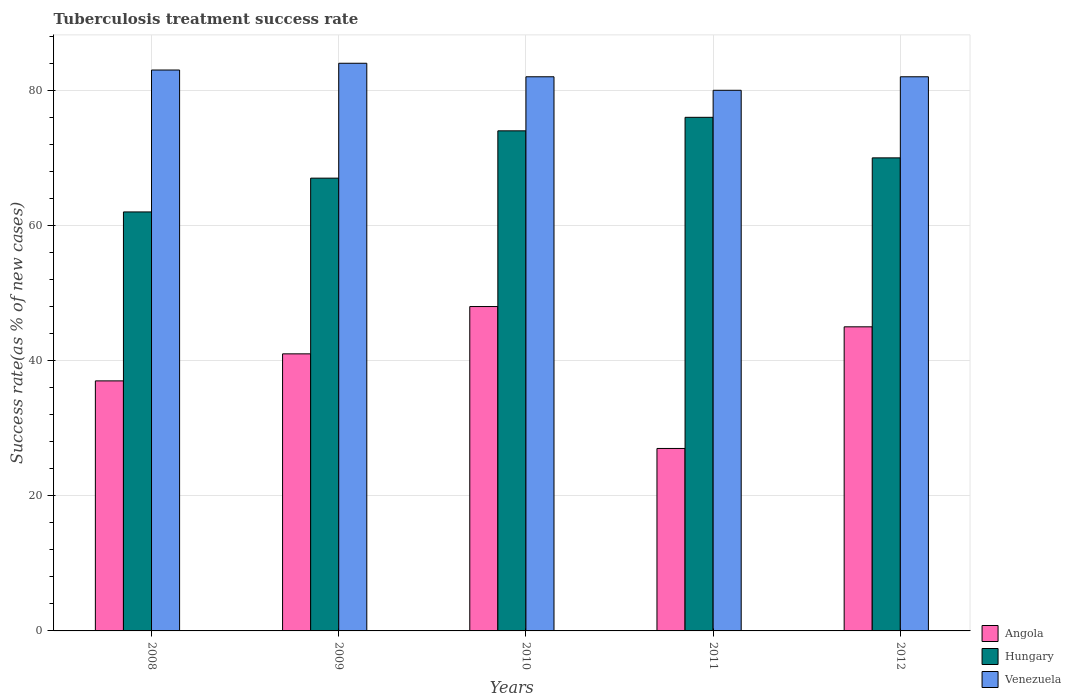How many groups of bars are there?
Offer a very short reply. 5. Are the number of bars on each tick of the X-axis equal?
Provide a succinct answer. Yes. In how many cases, is the number of bars for a given year not equal to the number of legend labels?
Ensure brevity in your answer.  0. What is the tuberculosis treatment success rate in Venezuela in 2008?
Offer a terse response. 83. In which year was the tuberculosis treatment success rate in Hungary maximum?
Ensure brevity in your answer.  2011. What is the total tuberculosis treatment success rate in Venezuela in the graph?
Keep it short and to the point. 411. What is the difference between the tuberculosis treatment success rate in Venezuela in 2008 and that in 2012?
Give a very brief answer. 1. What is the difference between the tuberculosis treatment success rate in Venezuela in 2008 and the tuberculosis treatment success rate in Angola in 2010?
Offer a very short reply. 35. What is the average tuberculosis treatment success rate in Venezuela per year?
Provide a short and direct response. 82.2. What is the ratio of the tuberculosis treatment success rate in Angola in 2010 to that in 2012?
Give a very brief answer. 1.07. Is the tuberculosis treatment success rate in Venezuela in 2009 less than that in 2011?
Make the answer very short. No. Is the difference between the tuberculosis treatment success rate in Venezuela in 2008 and 2011 greater than the difference between the tuberculosis treatment success rate in Hungary in 2008 and 2011?
Ensure brevity in your answer.  Yes. What is the difference between the highest and the lowest tuberculosis treatment success rate in Venezuela?
Make the answer very short. 4. In how many years, is the tuberculosis treatment success rate in Venezuela greater than the average tuberculosis treatment success rate in Venezuela taken over all years?
Offer a very short reply. 2. What does the 2nd bar from the left in 2009 represents?
Your answer should be very brief. Hungary. What does the 3rd bar from the right in 2008 represents?
Offer a terse response. Angola. Are all the bars in the graph horizontal?
Give a very brief answer. No. How many years are there in the graph?
Provide a short and direct response. 5. What is the difference between two consecutive major ticks on the Y-axis?
Ensure brevity in your answer.  20. Does the graph contain grids?
Your answer should be very brief. Yes. Where does the legend appear in the graph?
Keep it short and to the point. Bottom right. How many legend labels are there?
Make the answer very short. 3. How are the legend labels stacked?
Your answer should be compact. Vertical. What is the title of the graph?
Offer a very short reply. Tuberculosis treatment success rate. Does "Uzbekistan" appear as one of the legend labels in the graph?
Your answer should be very brief. No. What is the label or title of the Y-axis?
Provide a succinct answer. Success rate(as % of new cases). What is the Success rate(as % of new cases) in Hungary in 2008?
Give a very brief answer. 62. What is the Success rate(as % of new cases) in Venezuela in 2008?
Your answer should be very brief. 83. What is the Success rate(as % of new cases) of Hungary in 2010?
Offer a very short reply. 74. What is the Success rate(as % of new cases) of Venezuela in 2010?
Your answer should be very brief. 82. What is the Success rate(as % of new cases) in Angola in 2011?
Your response must be concise. 27. What is the Success rate(as % of new cases) of Hungary in 2011?
Your answer should be compact. 76. What is the Success rate(as % of new cases) in Angola in 2012?
Provide a succinct answer. 45. What is the Success rate(as % of new cases) of Hungary in 2012?
Your response must be concise. 70. Across all years, what is the maximum Success rate(as % of new cases) of Angola?
Provide a short and direct response. 48. Across all years, what is the maximum Success rate(as % of new cases) of Hungary?
Ensure brevity in your answer.  76. Across all years, what is the minimum Success rate(as % of new cases) in Venezuela?
Your answer should be very brief. 80. What is the total Success rate(as % of new cases) in Angola in the graph?
Your answer should be compact. 198. What is the total Success rate(as % of new cases) of Hungary in the graph?
Ensure brevity in your answer.  349. What is the total Success rate(as % of new cases) of Venezuela in the graph?
Give a very brief answer. 411. What is the difference between the Success rate(as % of new cases) of Venezuela in 2008 and that in 2009?
Your response must be concise. -1. What is the difference between the Success rate(as % of new cases) in Hungary in 2008 and that in 2011?
Make the answer very short. -14. What is the difference between the Success rate(as % of new cases) in Angola in 2008 and that in 2012?
Provide a succinct answer. -8. What is the difference between the Success rate(as % of new cases) of Hungary in 2008 and that in 2012?
Offer a very short reply. -8. What is the difference between the Success rate(as % of new cases) in Angola in 2009 and that in 2010?
Ensure brevity in your answer.  -7. What is the difference between the Success rate(as % of new cases) in Hungary in 2009 and that in 2010?
Your answer should be very brief. -7. What is the difference between the Success rate(as % of new cases) of Venezuela in 2009 and that in 2010?
Your answer should be very brief. 2. What is the difference between the Success rate(as % of new cases) of Venezuela in 2009 and that in 2011?
Offer a very short reply. 4. What is the difference between the Success rate(as % of new cases) of Angola in 2010 and that in 2011?
Offer a very short reply. 21. What is the difference between the Success rate(as % of new cases) of Venezuela in 2010 and that in 2011?
Your answer should be compact. 2. What is the difference between the Success rate(as % of new cases) of Venezuela in 2011 and that in 2012?
Your answer should be compact. -2. What is the difference between the Success rate(as % of new cases) of Angola in 2008 and the Success rate(as % of new cases) of Venezuela in 2009?
Give a very brief answer. -47. What is the difference between the Success rate(as % of new cases) of Hungary in 2008 and the Success rate(as % of new cases) of Venezuela in 2009?
Give a very brief answer. -22. What is the difference between the Success rate(as % of new cases) in Angola in 2008 and the Success rate(as % of new cases) in Hungary in 2010?
Offer a terse response. -37. What is the difference between the Success rate(as % of new cases) of Angola in 2008 and the Success rate(as % of new cases) of Venezuela in 2010?
Keep it short and to the point. -45. What is the difference between the Success rate(as % of new cases) of Hungary in 2008 and the Success rate(as % of new cases) of Venezuela in 2010?
Your response must be concise. -20. What is the difference between the Success rate(as % of new cases) of Angola in 2008 and the Success rate(as % of new cases) of Hungary in 2011?
Give a very brief answer. -39. What is the difference between the Success rate(as % of new cases) in Angola in 2008 and the Success rate(as % of new cases) in Venezuela in 2011?
Give a very brief answer. -43. What is the difference between the Success rate(as % of new cases) of Angola in 2008 and the Success rate(as % of new cases) of Hungary in 2012?
Offer a very short reply. -33. What is the difference between the Success rate(as % of new cases) in Angola in 2008 and the Success rate(as % of new cases) in Venezuela in 2012?
Make the answer very short. -45. What is the difference between the Success rate(as % of new cases) in Hungary in 2008 and the Success rate(as % of new cases) in Venezuela in 2012?
Keep it short and to the point. -20. What is the difference between the Success rate(as % of new cases) in Angola in 2009 and the Success rate(as % of new cases) in Hungary in 2010?
Offer a very short reply. -33. What is the difference between the Success rate(as % of new cases) of Angola in 2009 and the Success rate(as % of new cases) of Venezuela in 2010?
Keep it short and to the point. -41. What is the difference between the Success rate(as % of new cases) in Hungary in 2009 and the Success rate(as % of new cases) in Venezuela in 2010?
Give a very brief answer. -15. What is the difference between the Success rate(as % of new cases) of Angola in 2009 and the Success rate(as % of new cases) of Hungary in 2011?
Offer a terse response. -35. What is the difference between the Success rate(as % of new cases) of Angola in 2009 and the Success rate(as % of new cases) of Venezuela in 2011?
Make the answer very short. -39. What is the difference between the Success rate(as % of new cases) in Hungary in 2009 and the Success rate(as % of new cases) in Venezuela in 2011?
Your response must be concise. -13. What is the difference between the Success rate(as % of new cases) of Angola in 2009 and the Success rate(as % of new cases) of Venezuela in 2012?
Your answer should be compact. -41. What is the difference between the Success rate(as % of new cases) of Hungary in 2009 and the Success rate(as % of new cases) of Venezuela in 2012?
Offer a terse response. -15. What is the difference between the Success rate(as % of new cases) of Angola in 2010 and the Success rate(as % of new cases) of Hungary in 2011?
Your response must be concise. -28. What is the difference between the Success rate(as % of new cases) in Angola in 2010 and the Success rate(as % of new cases) in Venezuela in 2011?
Give a very brief answer. -32. What is the difference between the Success rate(as % of new cases) of Hungary in 2010 and the Success rate(as % of new cases) of Venezuela in 2011?
Your answer should be compact. -6. What is the difference between the Success rate(as % of new cases) in Angola in 2010 and the Success rate(as % of new cases) in Venezuela in 2012?
Your answer should be compact. -34. What is the difference between the Success rate(as % of new cases) in Hungary in 2010 and the Success rate(as % of new cases) in Venezuela in 2012?
Offer a terse response. -8. What is the difference between the Success rate(as % of new cases) in Angola in 2011 and the Success rate(as % of new cases) in Hungary in 2012?
Your answer should be very brief. -43. What is the difference between the Success rate(as % of new cases) in Angola in 2011 and the Success rate(as % of new cases) in Venezuela in 2012?
Your answer should be very brief. -55. What is the difference between the Success rate(as % of new cases) of Hungary in 2011 and the Success rate(as % of new cases) of Venezuela in 2012?
Make the answer very short. -6. What is the average Success rate(as % of new cases) in Angola per year?
Offer a very short reply. 39.6. What is the average Success rate(as % of new cases) in Hungary per year?
Provide a short and direct response. 69.8. What is the average Success rate(as % of new cases) of Venezuela per year?
Your answer should be very brief. 82.2. In the year 2008, what is the difference between the Success rate(as % of new cases) of Angola and Success rate(as % of new cases) of Hungary?
Provide a succinct answer. -25. In the year 2008, what is the difference between the Success rate(as % of new cases) in Angola and Success rate(as % of new cases) in Venezuela?
Offer a terse response. -46. In the year 2009, what is the difference between the Success rate(as % of new cases) in Angola and Success rate(as % of new cases) in Hungary?
Your answer should be compact. -26. In the year 2009, what is the difference between the Success rate(as % of new cases) of Angola and Success rate(as % of new cases) of Venezuela?
Provide a short and direct response. -43. In the year 2009, what is the difference between the Success rate(as % of new cases) in Hungary and Success rate(as % of new cases) in Venezuela?
Provide a short and direct response. -17. In the year 2010, what is the difference between the Success rate(as % of new cases) in Angola and Success rate(as % of new cases) in Hungary?
Provide a short and direct response. -26. In the year 2010, what is the difference between the Success rate(as % of new cases) in Angola and Success rate(as % of new cases) in Venezuela?
Keep it short and to the point. -34. In the year 2011, what is the difference between the Success rate(as % of new cases) of Angola and Success rate(as % of new cases) of Hungary?
Your answer should be compact. -49. In the year 2011, what is the difference between the Success rate(as % of new cases) of Angola and Success rate(as % of new cases) of Venezuela?
Your answer should be very brief. -53. In the year 2011, what is the difference between the Success rate(as % of new cases) in Hungary and Success rate(as % of new cases) in Venezuela?
Your answer should be very brief. -4. In the year 2012, what is the difference between the Success rate(as % of new cases) in Angola and Success rate(as % of new cases) in Hungary?
Your answer should be compact. -25. In the year 2012, what is the difference between the Success rate(as % of new cases) of Angola and Success rate(as % of new cases) of Venezuela?
Your answer should be compact. -37. What is the ratio of the Success rate(as % of new cases) in Angola in 2008 to that in 2009?
Offer a terse response. 0.9. What is the ratio of the Success rate(as % of new cases) of Hungary in 2008 to that in 2009?
Make the answer very short. 0.93. What is the ratio of the Success rate(as % of new cases) in Venezuela in 2008 to that in 2009?
Your answer should be compact. 0.99. What is the ratio of the Success rate(as % of new cases) of Angola in 2008 to that in 2010?
Your answer should be very brief. 0.77. What is the ratio of the Success rate(as % of new cases) in Hungary in 2008 to that in 2010?
Your answer should be very brief. 0.84. What is the ratio of the Success rate(as % of new cases) of Venezuela in 2008 to that in 2010?
Offer a terse response. 1.01. What is the ratio of the Success rate(as % of new cases) in Angola in 2008 to that in 2011?
Your answer should be very brief. 1.37. What is the ratio of the Success rate(as % of new cases) of Hungary in 2008 to that in 2011?
Offer a very short reply. 0.82. What is the ratio of the Success rate(as % of new cases) in Venezuela in 2008 to that in 2011?
Offer a terse response. 1.04. What is the ratio of the Success rate(as % of new cases) of Angola in 2008 to that in 2012?
Provide a short and direct response. 0.82. What is the ratio of the Success rate(as % of new cases) in Hungary in 2008 to that in 2012?
Provide a succinct answer. 0.89. What is the ratio of the Success rate(as % of new cases) in Venezuela in 2008 to that in 2012?
Offer a terse response. 1.01. What is the ratio of the Success rate(as % of new cases) in Angola in 2009 to that in 2010?
Provide a short and direct response. 0.85. What is the ratio of the Success rate(as % of new cases) of Hungary in 2009 to that in 2010?
Give a very brief answer. 0.91. What is the ratio of the Success rate(as % of new cases) of Venezuela in 2009 to that in 2010?
Offer a very short reply. 1.02. What is the ratio of the Success rate(as % of new cases) of Angola in 2009 to that in 2011?
Make the answer very short. 1.52. What is the ratio of the Success rate(as % of new cases) in Hungary in 2009 to that in 2011?
Your answer should be very brief. 0.88. What is the ratio of the Success rate(as % of new cases) in Venezuela in 2009 to that in 2011?
Provide a short and direct response. 1.05. What is the ratio of the Success rate(as % of new cases) in Angola in 2009 to that in 2012?
Make the answer very short. 0.91. What is the ratio of the Success rate(as % of new cases) in Hungary in 2009 to that in 2012?
Provide a succinct answer. 0.96. What is the ratio of the Success rate(as % of new cases) in Venezuela in 2009 to that in 2012?
Your response must be concise. 1.02. What is the ratio of the Success rate(as % of new cases) of Angola in 2010 to that in 2011?
Offer a very short reply. 1.78. What is the ratio of the Success rate(as % of new cases) in Hungary in 2010 to that in 2011?
Provide a succinct answer. 0.97. What is the ratio of the Success rate(as % of new cases) of Angola in 2010 to that in 2012?
Your response must be concise. 1.07. What is the ratio of the Success rate(as % of new cases) of Hungary in 2010 to that in 2012?
Give a very brief answer. 1.06. What is the ratio of the Success rate(as % of new cases) of Venezuela in 2010 to that in 2012?
Provide a succinct answer. 1. What is the ratio of the Success rate(as % of new cases) in Angola in 2011 to that in 2012?
Keep it short and to the point. 0.6. What is the ratio of the Success rate(as % of new cases) in Hungary in 2011 to that in 2012?
Ensure brevity in your answer.  1.09. What is the ratio of the Success rate(as % of new cases) in Venezuela in 2011 to that in 2012?
Your answer should be very brief. 0.98. What is the difference between the highest and the second highest Success rate(as % of new cases) in Angola?
Offer a terse response. 3. What is the difference between the highest and the second highest Success rate(as % of new cases) of Venezuela?
Provide a succinct answer. 1. What is the difference between the highest and the lowest Success rate(as % of new cases) of Angola?
Your answer should be compact. 21. What is the difference between the highest and the lowest Success rate(as % of new cases) in Hungary?
Ensure brevity in your answer.  14. 